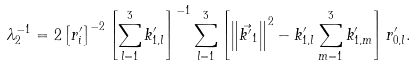<formula> <loc_0><loc_0><loc_500><loc_500>\lambda _ { 2 } ^ { - 1 } & = 2 \left [ r ^ { \prime } _ { i } \right ] ^ { - 2 } \left [ \sum _ { l = 1 } ^ { 3 } k ^ { \prime } _ { 1 , l } \right ] ^ { - 1 } \sum _ { l = 1 } ^ { 3 } \left [ \left \| \vec { k ^ { \prime } } _ { 1 } \right \| ^ { 2 } - k ^ { \prime } _ { 1 , l } \sum _ { m = 1 } ^ { 3 } k ^ { \prime } _ { 1 , m } \right ] r ^ { \prime } _ { 0 , l } .</formula> 